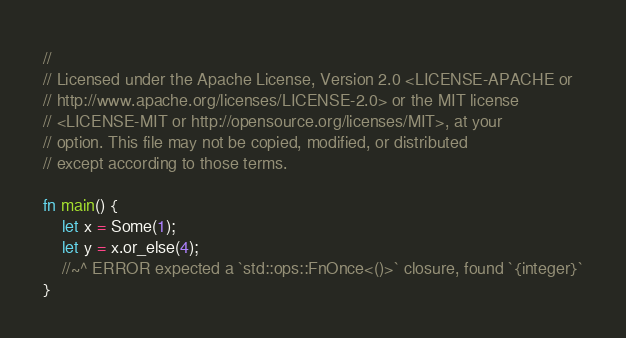Convert code to text. <code><loc_0><loc_0><loc_500><loc_500><_Rust_>//
// Licensed under the Apache License, Version 2.0 <LICENSE-APACHE or
// http://www.apache.org/licenses/LICENSE-2.0> or the MIT license
// <LICENSE-MIT or http://opensource.org/licenses/MIT>, at your
// option. This file may not be copied, modified, or distributed
// except according to those terms.

fn main() {
    let x = Some(1);
    let y = x.or_else(4);
    //~^ ERROR expected a `std::ops::FnOnce<()>` closure, found `{integer}`
}
</code> 